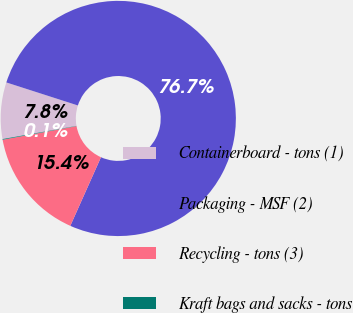Convert chart to OTSL. <chart><loc_0><loc_0><loc_500><loc_500><pie_chart><fcel>Containerboard - tons (1)<fcel>Packaging - MSF (2)<fcel>Recycling - tons (3)<fcel>Kraft bags and sacks - tons<nl><fcel>7.76%<fcel>76.73%<fcel>15.42%<fcel>0.09%<nl></chart> 